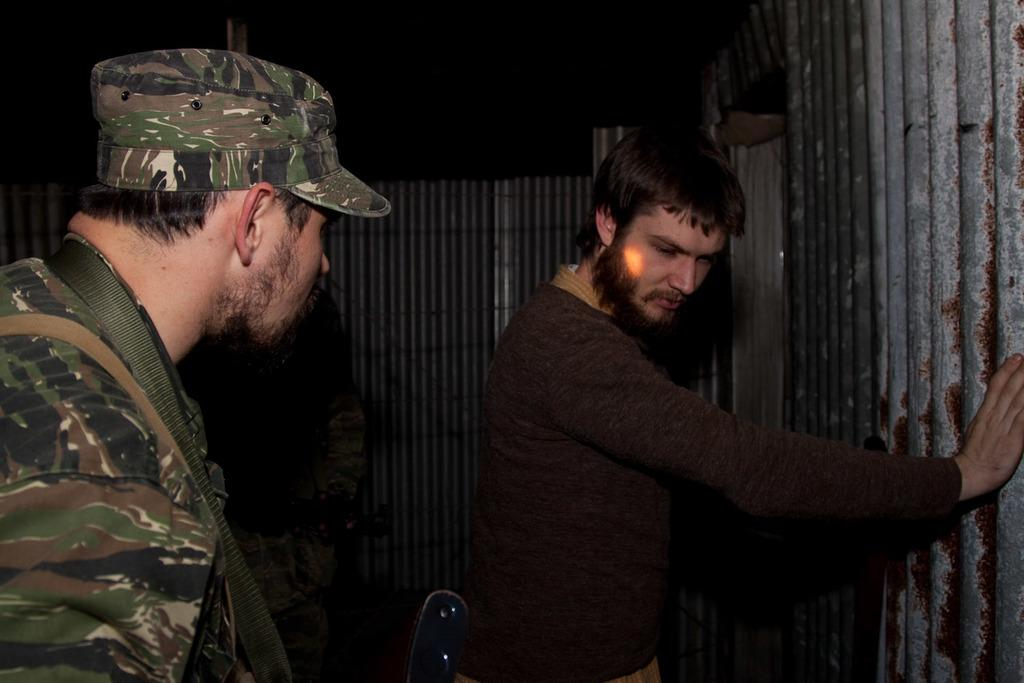How many people are in the image? There are two men in the image. Where is the man on the left side of the image located? The man on the left side of the image is located on the left side of the image. What is the man on the left side wearing? The man on the left side is wearing a cap. What can be seen in the background of the image? Sheets are visible in the background of the image. What type of acoustics can be heard in the image? There is no information about any sounds or acoustics in the image, so it cannot be determined. --- Facts: 1. There is a car in the image. 2. The car is red. 3. The car has four wheels. 4. There are people in the car. 5. The car is parked on the street. Absurd Topics: dance, ocean, sculpture Conversation: What is the main subject of the image? The main subject of the image is a car. What color is the car? The car is red. How many wheels does the car have? The car has four wheels. Are there any passengers in the car? Yes, there are people in the car. Where is the car located in the image? The car is parked on the street. Reasoning: Let's think step by step in order to produce the conversation. We start by identifying the main subject of the image, which is the car. Then, we describe the color and number of wheels of the car. Next, we mention the presence of passengers in the car. Finally, we describe the location of the car, which is parked on the street. Absurd Question/Answer: Can you see any sculptures in the image? There is no mention of a sculpture in the image, so it cannot be determined if one is present. 